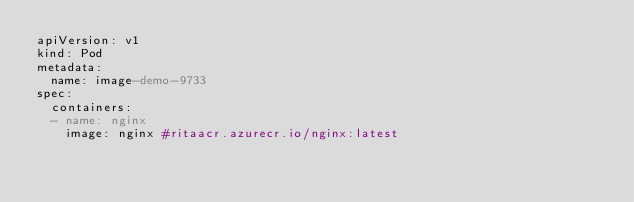Convert code to text. <code><loc_0><loc_0><loc_500><loc_500><_YAML_>apiVersion: v1
kind: Pod
metadata:
  name: image-demo-9733
spec:
  containers:
  - name: nginx
    image: nginx #ritaacr.azurecr.io/nginx:latest</code> 